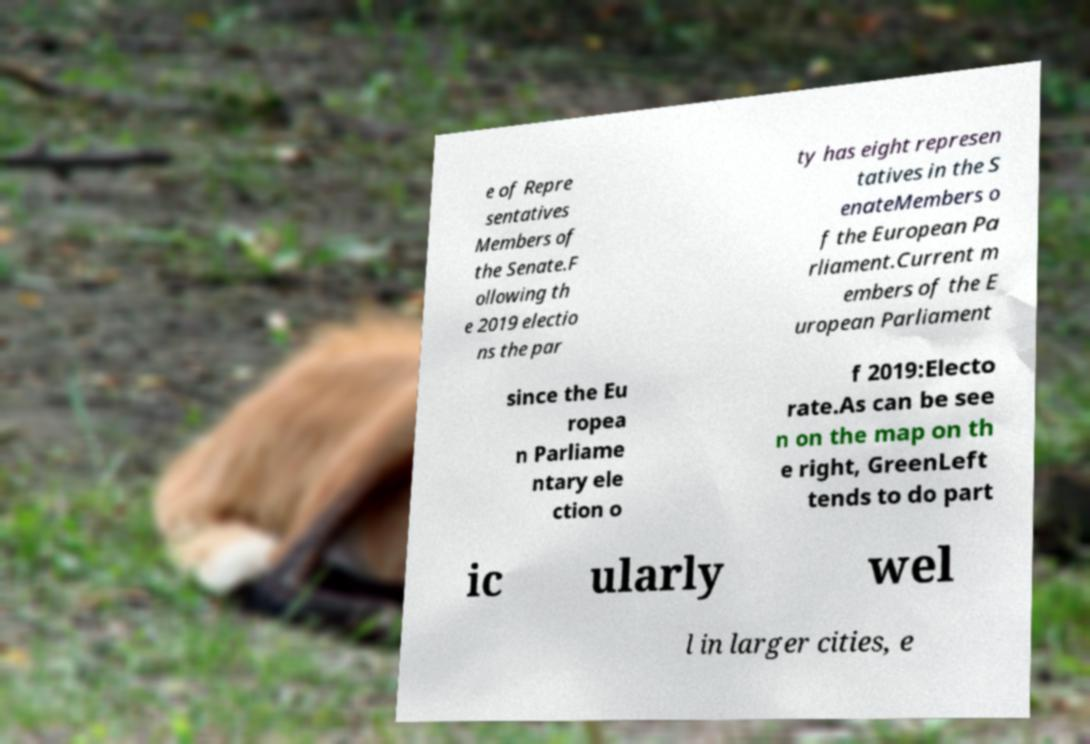Can you accurately transcribe the text from the provided image for me? e of Repre sentatives Members of the Senate.F ollowing th e 2019 electio ns the par ty has eight represen tatives in the S enateMembers o f the European Pa rliament.Current m embers of the E uropean Parliament since the Eu ropea n Parliame ntary ele ction o f 2019:Electo rate.As can be see n on the map on th e right, GreenLeft tends to do part ic ularly wel l in larger cities, e 